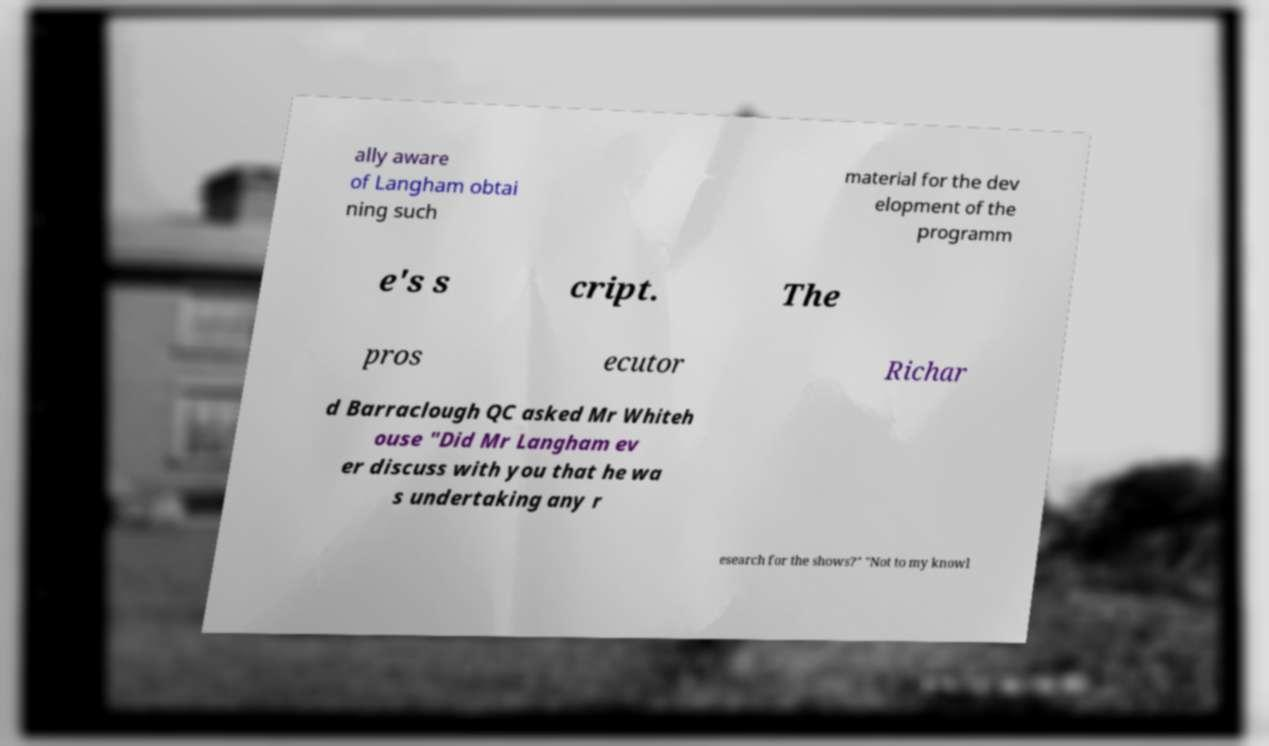Please read and relay the text visible in this image. What does it say? ally aware of Langham obtai ning such material for the dev elopment of the programm e's s cript. The pros ecutor Richar d Barraclough QC asked Mr Whiteh ouse "Did Mr Langham ev er discuss with you that he wa s undertaking any r esearch for the shows?" "Not to my knowl 